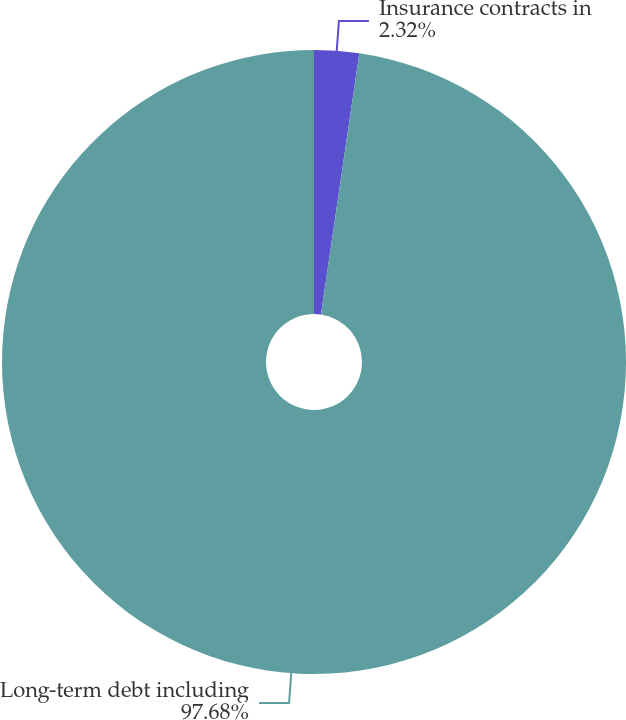Convert chart. <chart><loc_0><loc_0><loc_500><loc_500><pie_chart><fcel>Insurance contracts in<fcel>Long-term debt including<nl><fcel>2.32%<fcel>97.68%<nl></chart> 